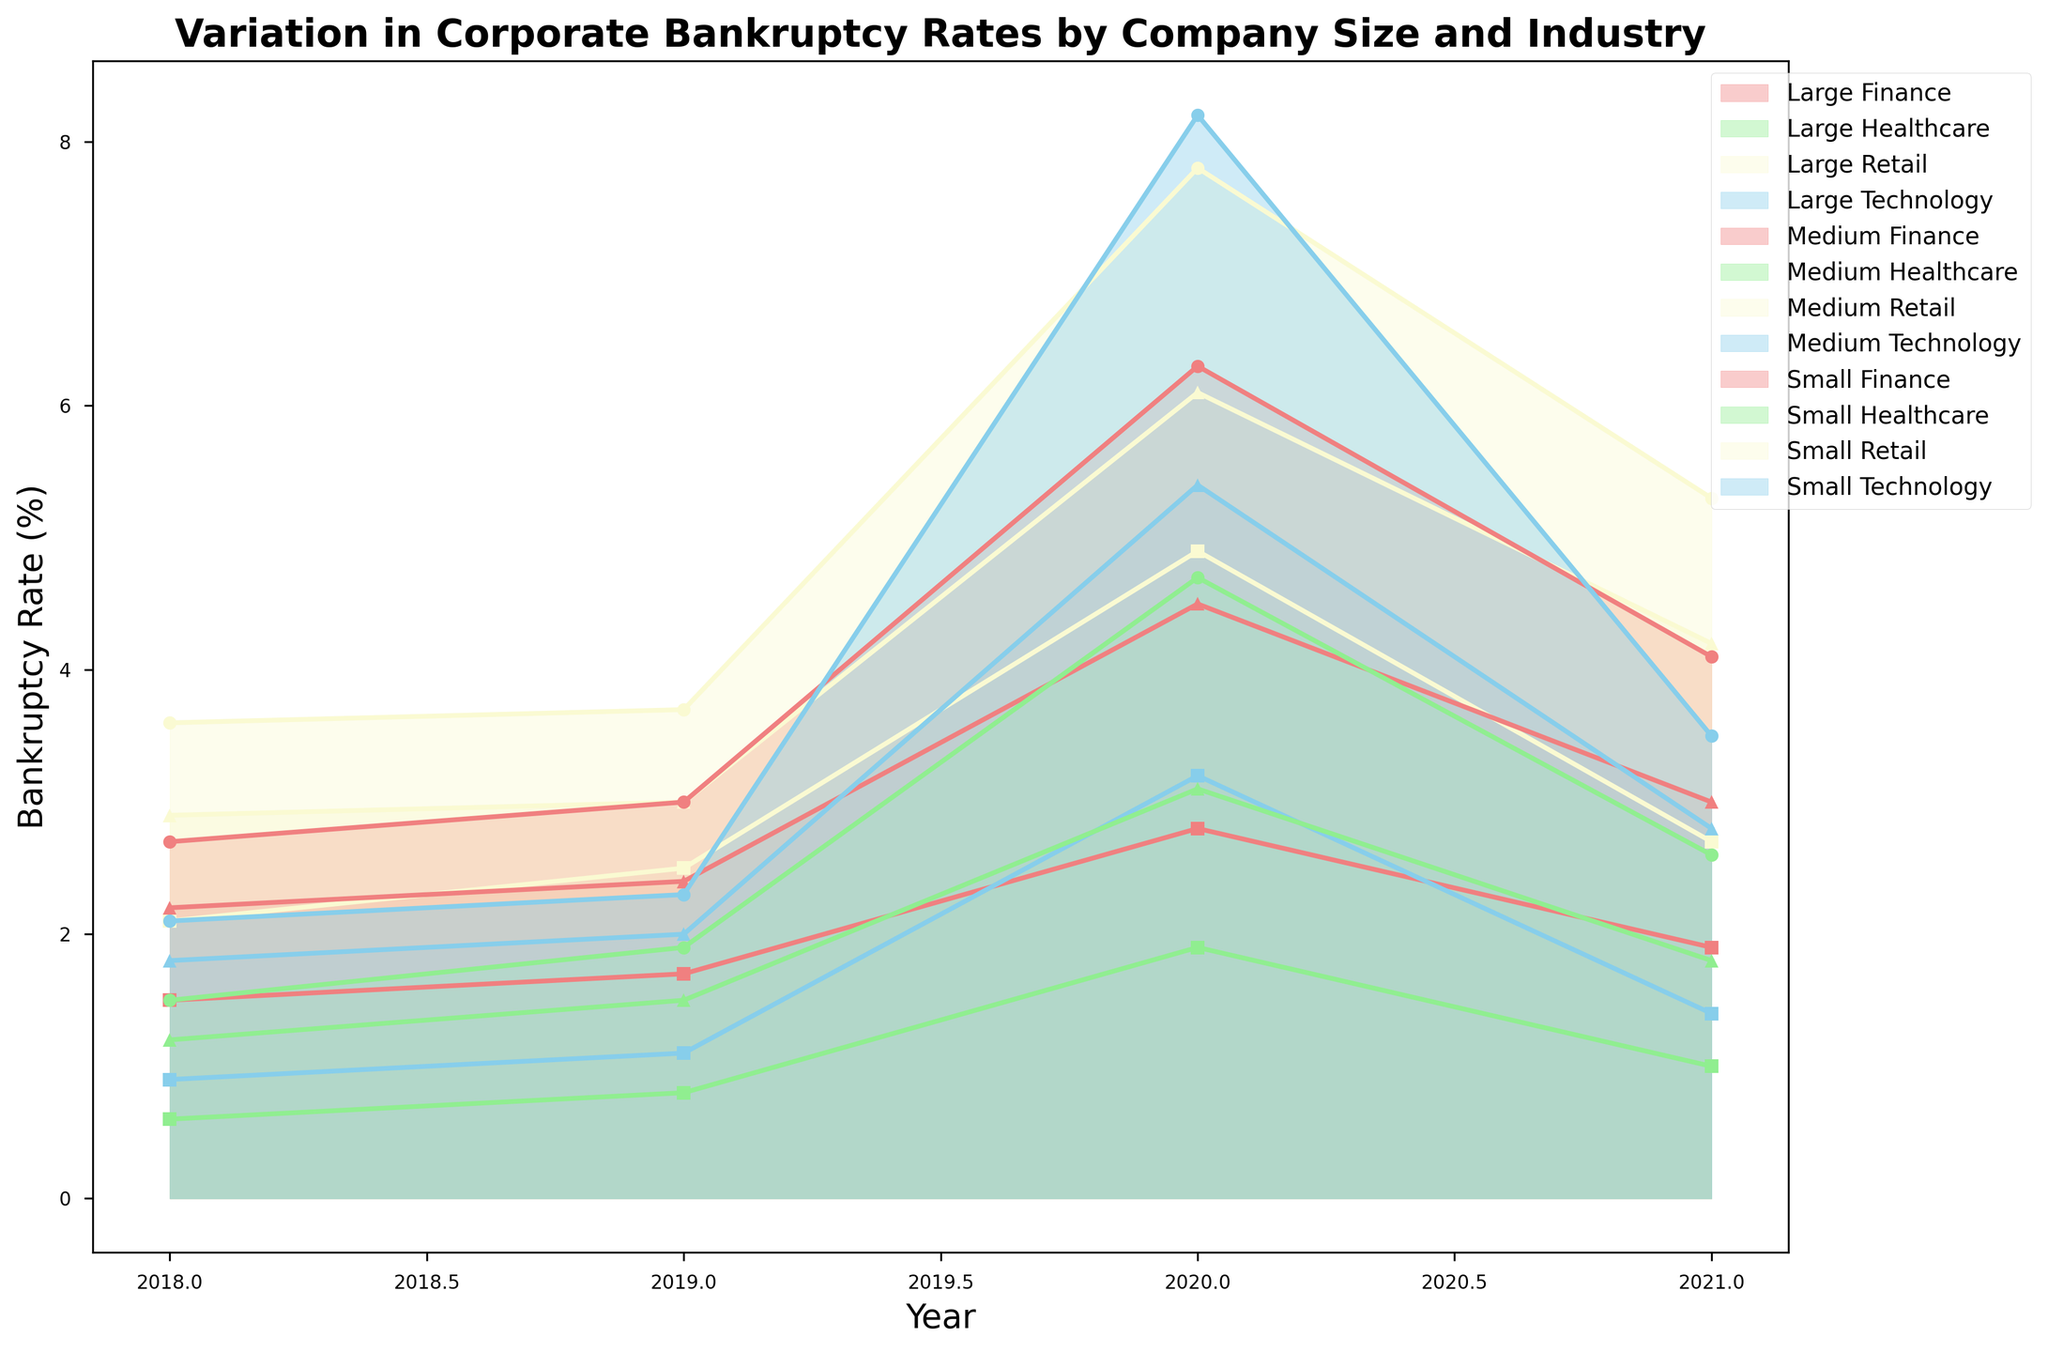What industry experienced the highest bankruptcy rate among small companies in 2020? Observing the plot, the area corresponding to small companies in the Technology industry peaked highest in 2020.
Answer: Technology Compare the bankruptcy rates of medium-sized companies in Retail and Finance industries in 2019. Which one is higher and by how much? Locate the 2019 point for medium-sized Retail and Finance companies for comparison. Retail has a rate of 3.0%, and Finance has a rate of 2.4%. Thus, Retail's rate is higher. 3.0% - 2.4% = 0.6%.
Answer: Retail; 0.6% What is the trend of bankruptcy rates for large companies in the Healthcare industry from 2018 to 2021? Examine the line for large Healthcare companies from 2018 to 2021. The rates increased from 0.6% in 2018 to 0.8% in 2019, spiked to 1.9% in 2020, then dropped to 1.0% in 2021.
Answer: Increase-decrease Which company size and industry combination had the most significant decrease in bankruptcy rates from 2020 to 2021? Compare the differences between 2020 and 2021 across all groups. Small Technology drops from 8.2% to 3.5%, the highest reduction.
Answer: Small Technology What was the bankruptcy rate for large companies in the Technology industry in 2018, and how does it compare to 2019? Look at the 2018 and 2019 data points for large Technology companies. The rate was 0.9% in 2018 and 1.1% in 2019. 1.1% - 0.9% = 0.2% increase.
Answer: 0.9%, 0.2% increase What is the average bankruptcy rate for medium companies in the Finance industry over the four years plotted? Calculate the average of the four data points for medium Finance: (2.2% + 2.4% + 4.5% + 3.0%) / 4 = 3.025%.
Answer: 3.025% Identify the year where small companies in the Retail industry faced the peak bankruptcy rate. What was the rate? Look for the highest point in the line for small Retail companies. The peak is in 2020 with a rate of 7.8%.
Answer: 2020, 7.8% How do the bankruptcy rates for large companies in the Finance industry in 2020 and 2021 compare, and what is the percentage decrease? Find the respective points for large Finance companies, where rates are 2.8% in 2020 and 1.9% in 2021. (2.8% - 1.9%) / 2.8% * 100% = 32.14% decrease.
Answer: 2.8%, 1.9%; 32.14% decrease 